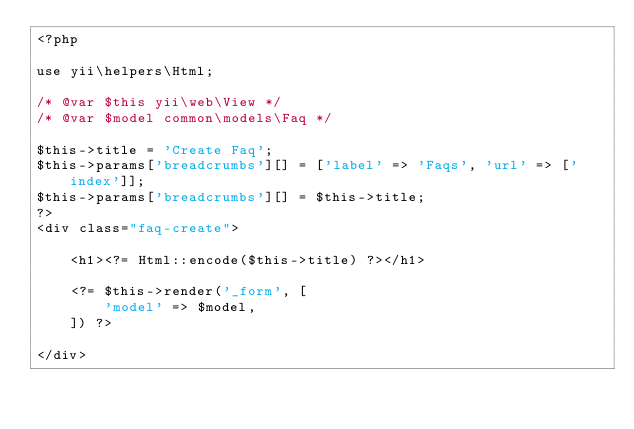<code> <loc_0><loc_0><loc_500><loc_500><_PHP_><?php

use yii\helpers\Html;

/* @var $this yii\web\View */
/* @var $model common\models\Faq */

$this->title = 'Create Faq';
$this->params['breadcrumbs'][] = ['label' => 'Faqs', 'url' => ['index']];
$this->params['breadcrumbs'][] = $this->title;
?>
<div class="faq-create">

    <h1><?= Html::encode($this->title) ?></h1>

    <?= $this->render('_form', [
        'model' => $model,
    ]) ?>

</div>
</code> 